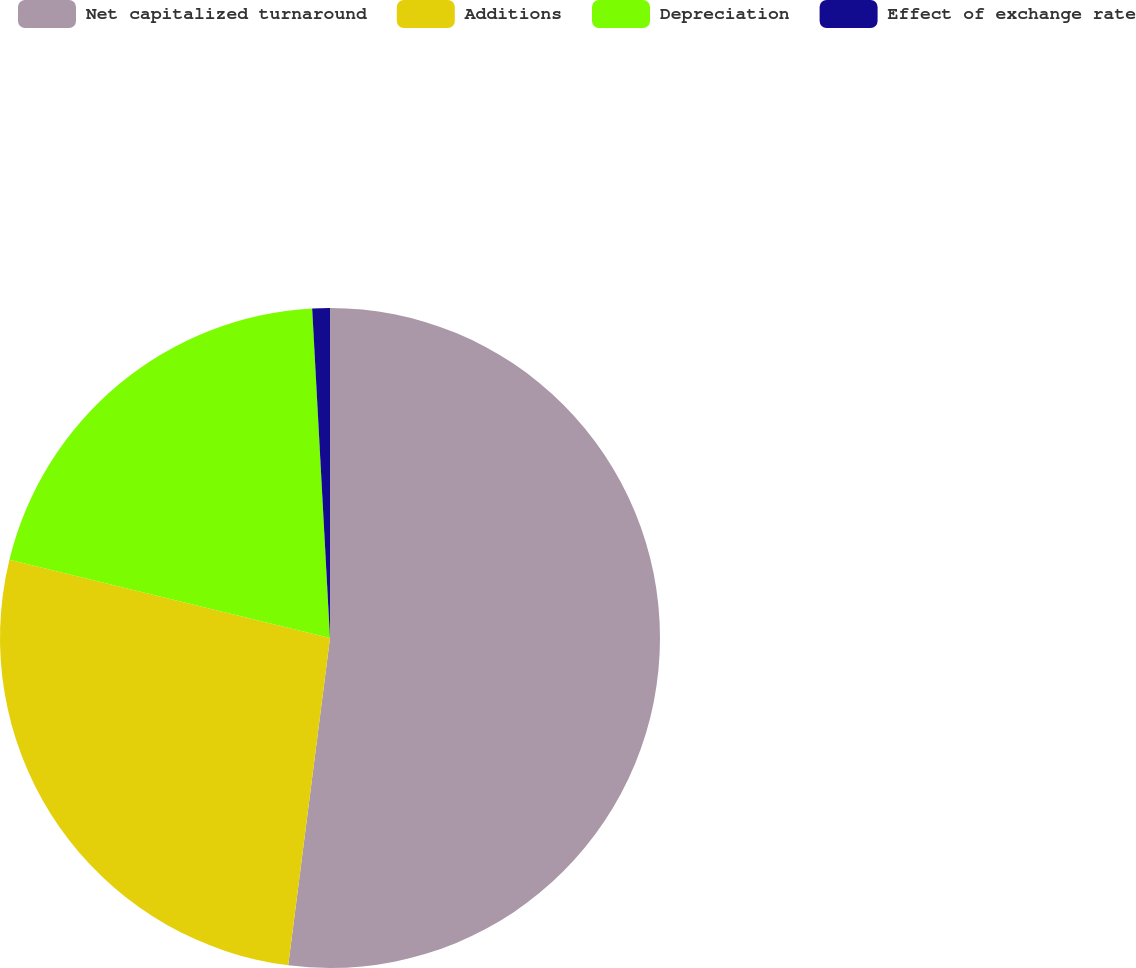<chart> <loc_0><loc_0><loc_500><loc_500><pie_chart><fcel>Net capitalized turnaround<fcel>Additions<fcel>Depreciation<fcel>Effect of exchange rate<nl><fcel>52.02%<fcel>26.79%<fcel>20.33%<fcel>0.86%<nl></chart> 